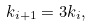<formula> <loc_0><loc_0><loc_500><loc_500>k _ { i + 1 } = 3 k _ { i } ,</formula> 